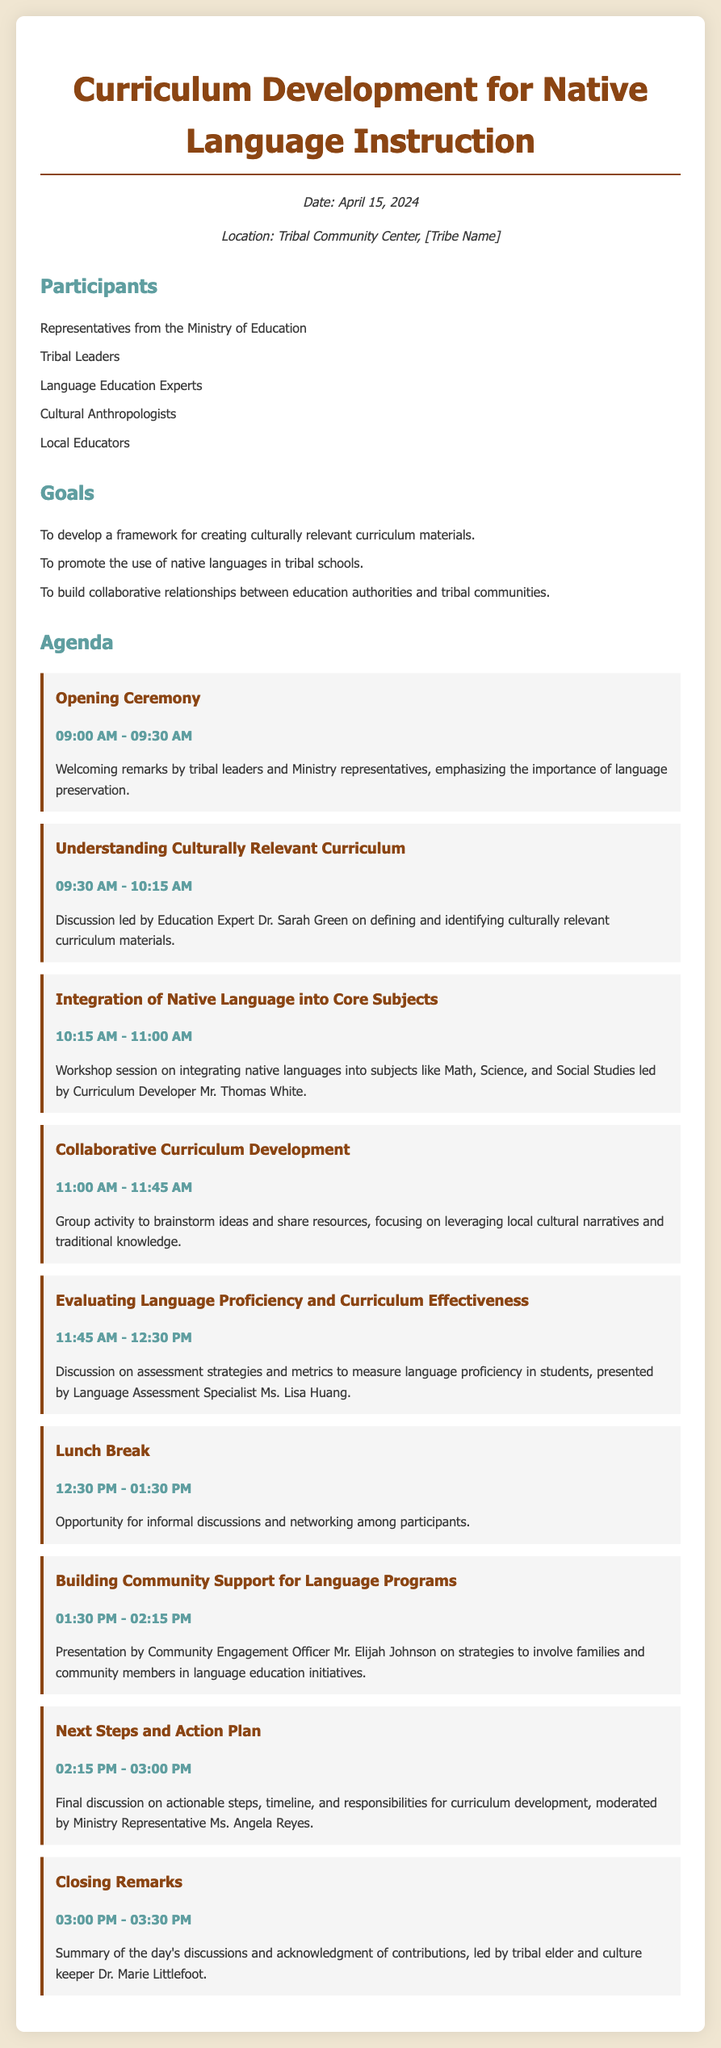What is the date of the event? The date is specified in the document under the info section, which states "Date: April 15, 2024."
Answer: April 15, 2024 Who is leading the discussion on culturally relevant curriculum? The document mentions that Education Expert Dr. Sarah Green will lead this discussion.
Answer: Dr. Sarah Green What time does the lunch break start? The schedule lists the lunch break starting at "12:30 PM."
Answer: 12:30 PM How long is the duration for the closing remarks? The document states that the closing remarks will occur from "03:00 PM - 03:30 PM," lasting 30 minutes.
Answer: 30 minutes Which participant is responsible for the next steps and action plan? The agenda states that Ministry Representative Ms. Angela Reyes will moderate this session.
Answer: Ms. Angela Reyes What session focuses on integrating native language into core subjects? The agenda includes a session with this focus led by Curriculum Developer Mr. Thomas White.
Answer: Integration of Native Language into Core Subjects What is the main goal of the agenda? The document lists developing a framework for creating culturally relevant curriculum materials as one of the goals.
Answer: Developing a framework for creating culturally relevant curriculum materials What type of session is scheduled for 11:00 AM? The agenda describes this as a group activity to brainstorm ideas.
Answer: Group activity Who will give the presentation on community support for language programs? The document identifies Community Engagement Officer Mr. Elijah Johnson as the presenter for this topic.
Answer: Mr. Elijah Johnson 